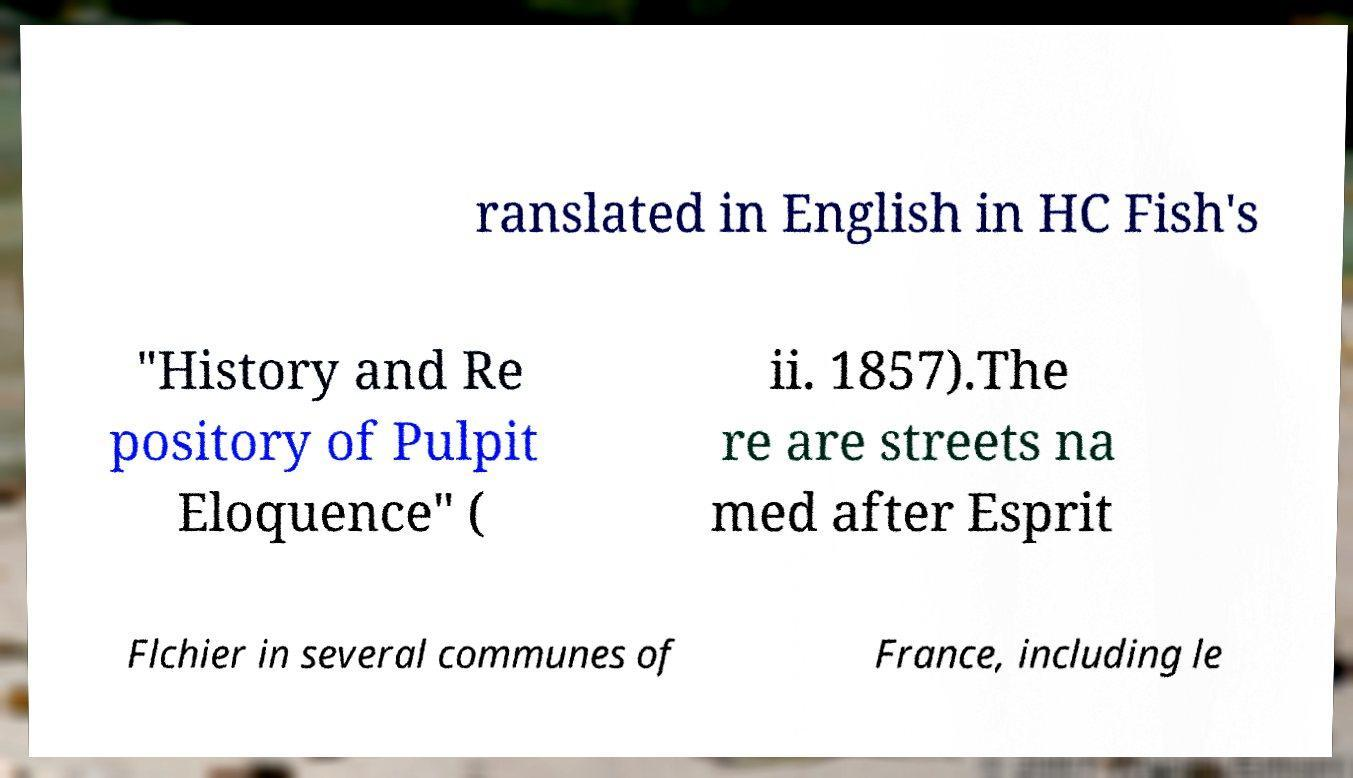For documentation purposes, I need the text within this image transcribed. Could you provide that? ranslated in English in HC Fish's "History and Re pository of Pulpit Eloquence" ( ii. 1857).The re are streets na med after Esprit Flchier in several communes of France, including le 